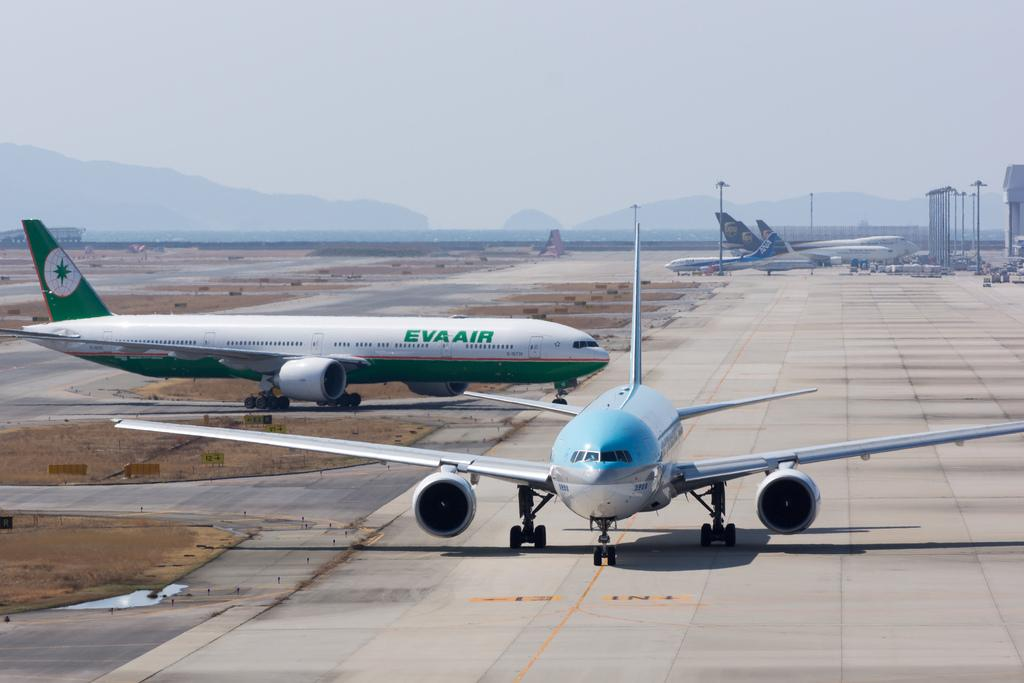What unusual subject can be seen on the road in the image? There are aeroplanes on the road in the image. What can be seen in the background of the image? There are poles, a tower, hills, and buildings visible in the background of the image. What is visible at the top of the image? The sky is visible at the top of the image. Where is the cracker being stored in the image? There is no cracker present in the image. What type of home can be seen in the image? There is no home visible in the image. Is there a prison in the image? There is no prison present in the image. 